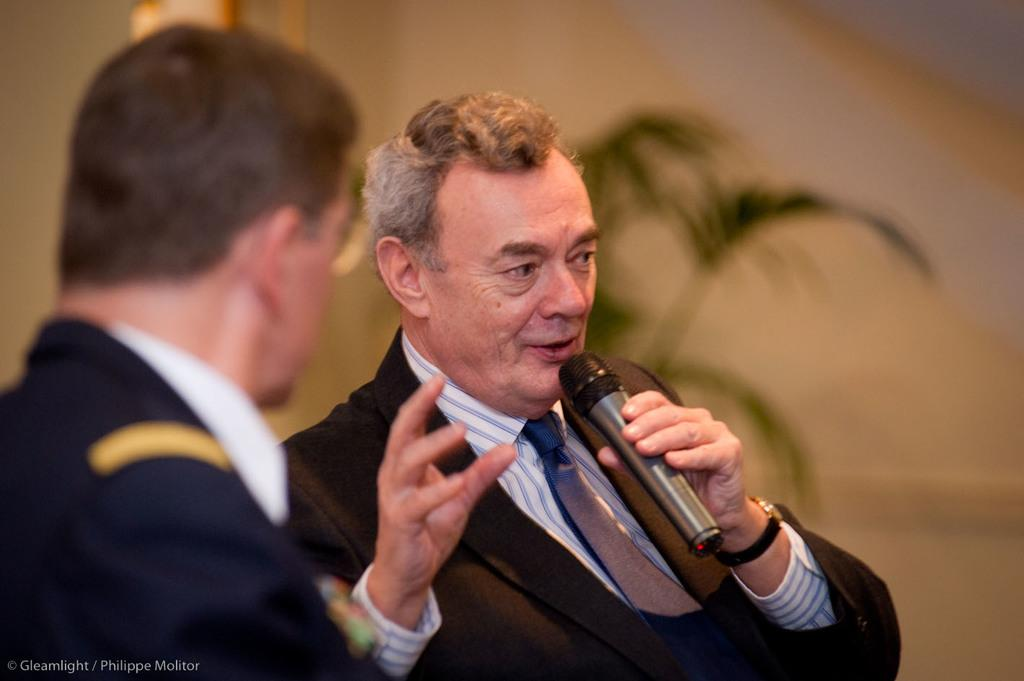What is the person in the image holding? The person is holding a microphone in the image. Can you describe the other person in the image? There is another person in the image, but no specific details are provided about them. What can be seen in the background of the image? There is a plant in the background of the image. Is there any additional information about the image itself? Yes, there is a watermark on the image. What type of pickle is being used as a prop in the image? There is no pickle present in the image. 